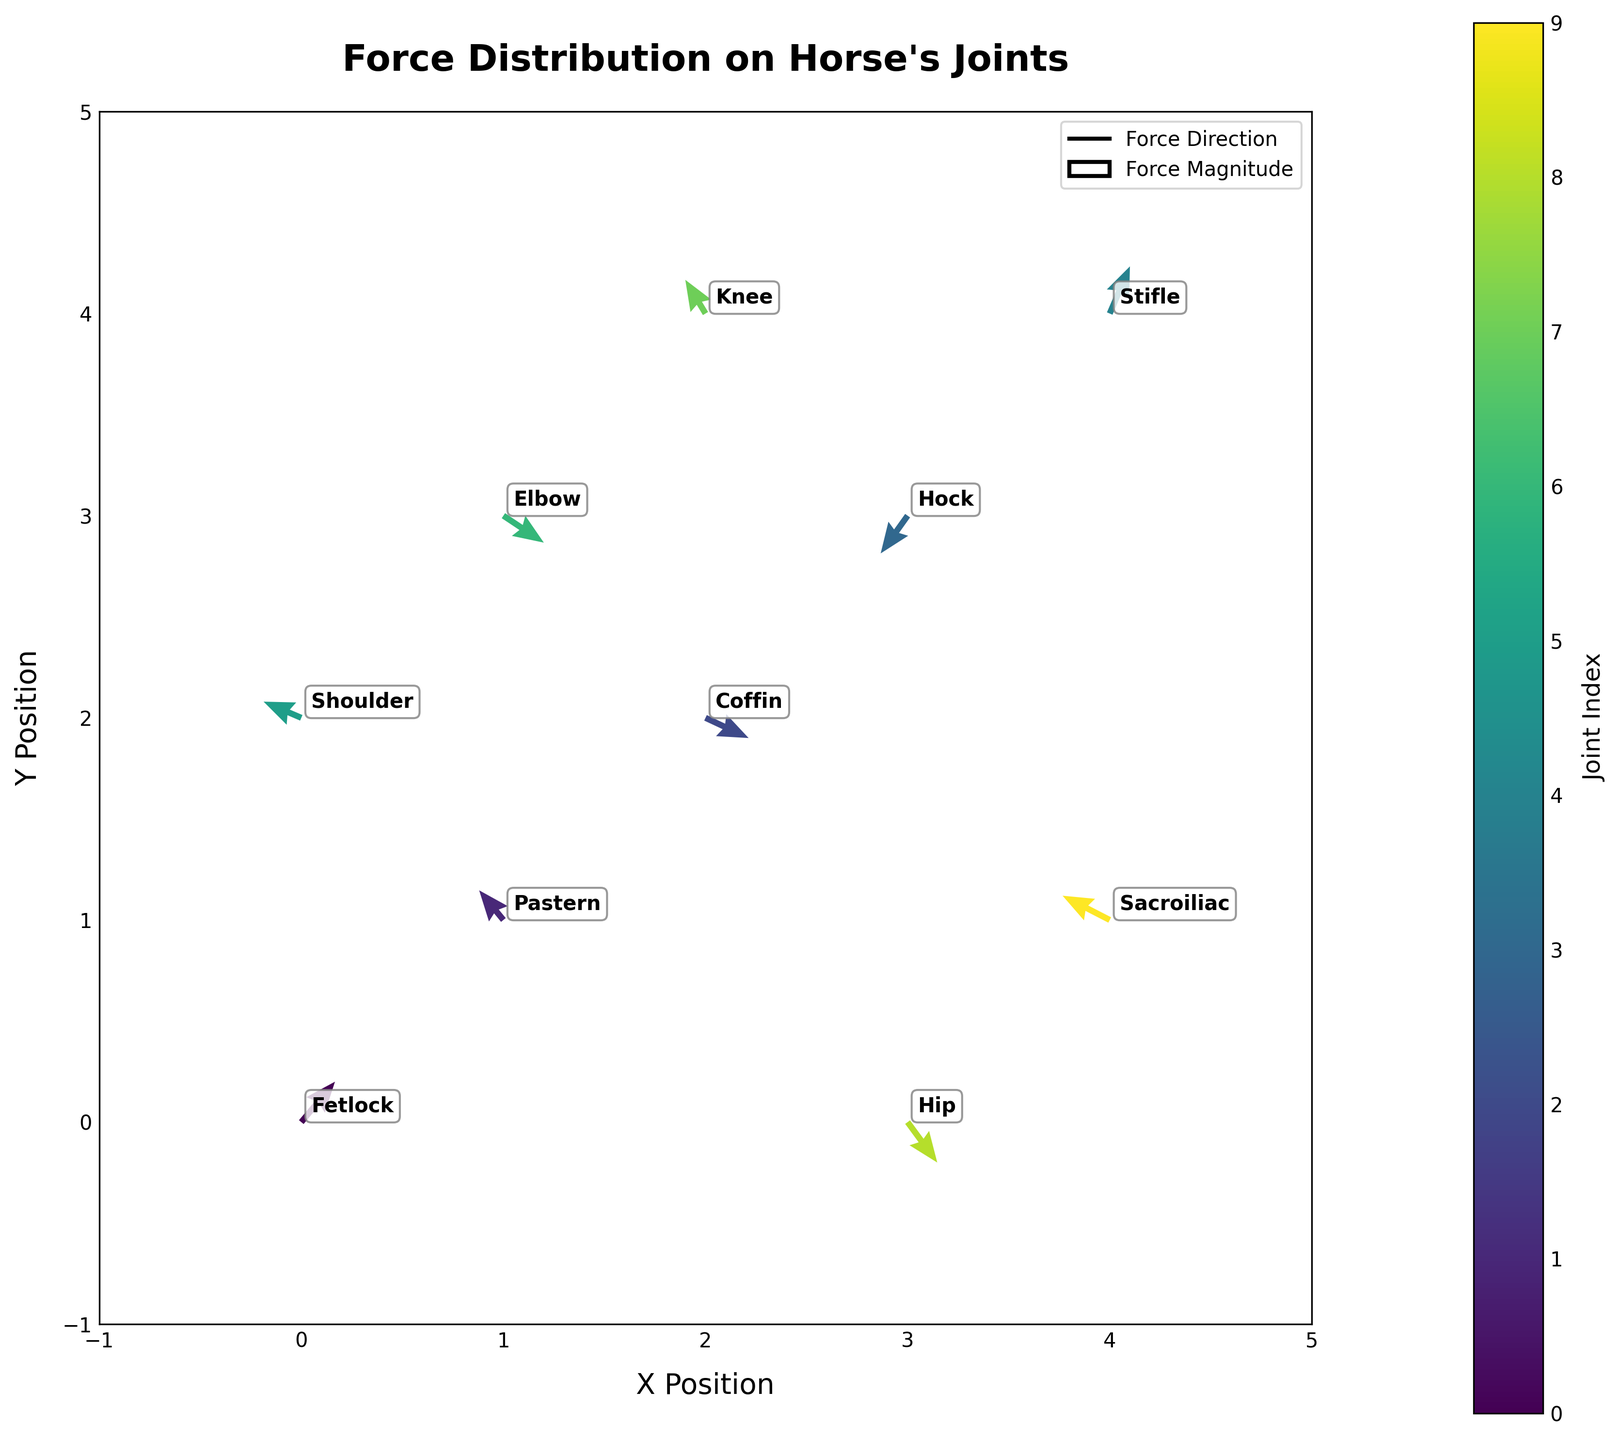Which joint experiences a force vector with the largest horizontal component in the positive x-direction? Look at the arrows (force vectors) in the plot and compare their horizontal components (u). The joint with the largest positive x-direction component is the one with the longest arrow in the positive x-direction. The Coffin joint has the largest horizontal component (u=3.2) in the positive x-direction.
Answer: Coffin What is the total horizontal force acting on the Stifle and Shoulder joints? The horizontal forces (u components) for the Stifle and Shoulder joints need to be summed. The Stifle joint has a u value of 1.5, and the Shoulder joint has a u value of -2.8. Summing these, 1.5 + (-2.8) = -1.3.
Answer: -1.3 Which joint has the largest magnitude of force in the negative y-direction? To find this, look at the y-components (v) of the force vectors pointing in the negative y-direction and find the one with the largest magnitude. The Hock joint has the largest negative y-component of -2.8.
Answer: Hock What is the average horizontal force component (u) among all the joints? Sum the horizontal force components (u) of all the joints and divide by the total number of joints (10). The sum is 2.5 + (-1.8) + 3.2 + (-2.0) + 1.5 + (-2.8) + 3.0 + (-1.5) + 2.2 + (-3.5) = 0.8. The average is 0.8/10 = 0.08.
Answer: 0.08 